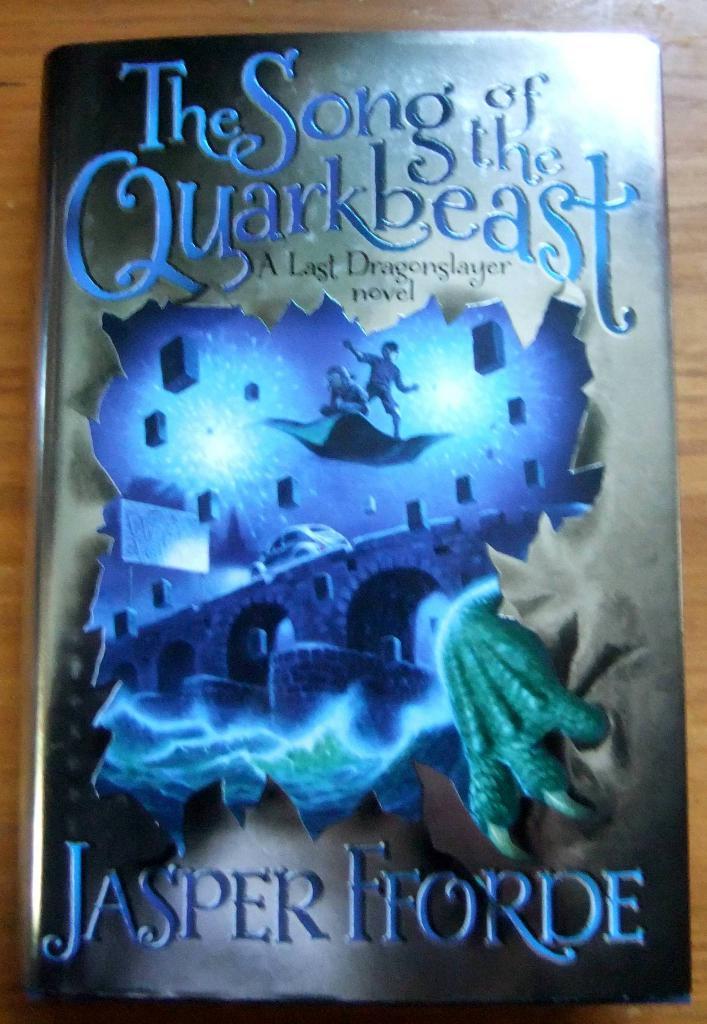What is the title of the book?
Offer a terse response. The song of the quarkbeast. 